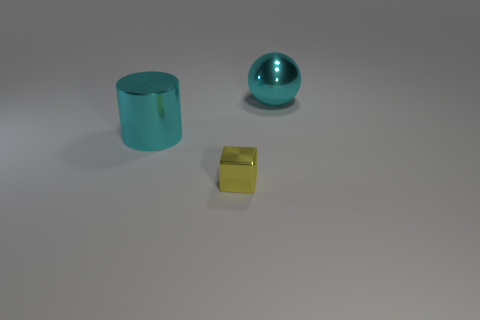Are there any other things of the same color as the cylinder?
Provide a succinct answer. Yes. The small thing that is the same material as the big cylinder is what shape?
Ensure brevity in your answer.  Cube. Is the cylinder the same color as the block?
Keep it short and to the point. No. Is the object that is behind the big shiny cylinder made of the same material as the object in front of the large cylinder?
Your answer should be compact. Yes. What number of things are either tiny matte spheres or shiny things right of the large cyan shiny cylinder?
Provide a succinct answer. 2. Is there anything else that is the same material as the tiny cube?
Offer a very short reply. Yes. There is a big metal thing that is the same color as the big metallic cylinder; what shape is it?
Offer a terse response. Sphere. What material is the yellow cube?
Your answer should be very brief. Metal. Are the small thing and the cyan ball made of the same material?
Your response must be concise. Yes. How many metallic objects are cyan spheres or small blocks?
Provide a succinct answer. 2. 